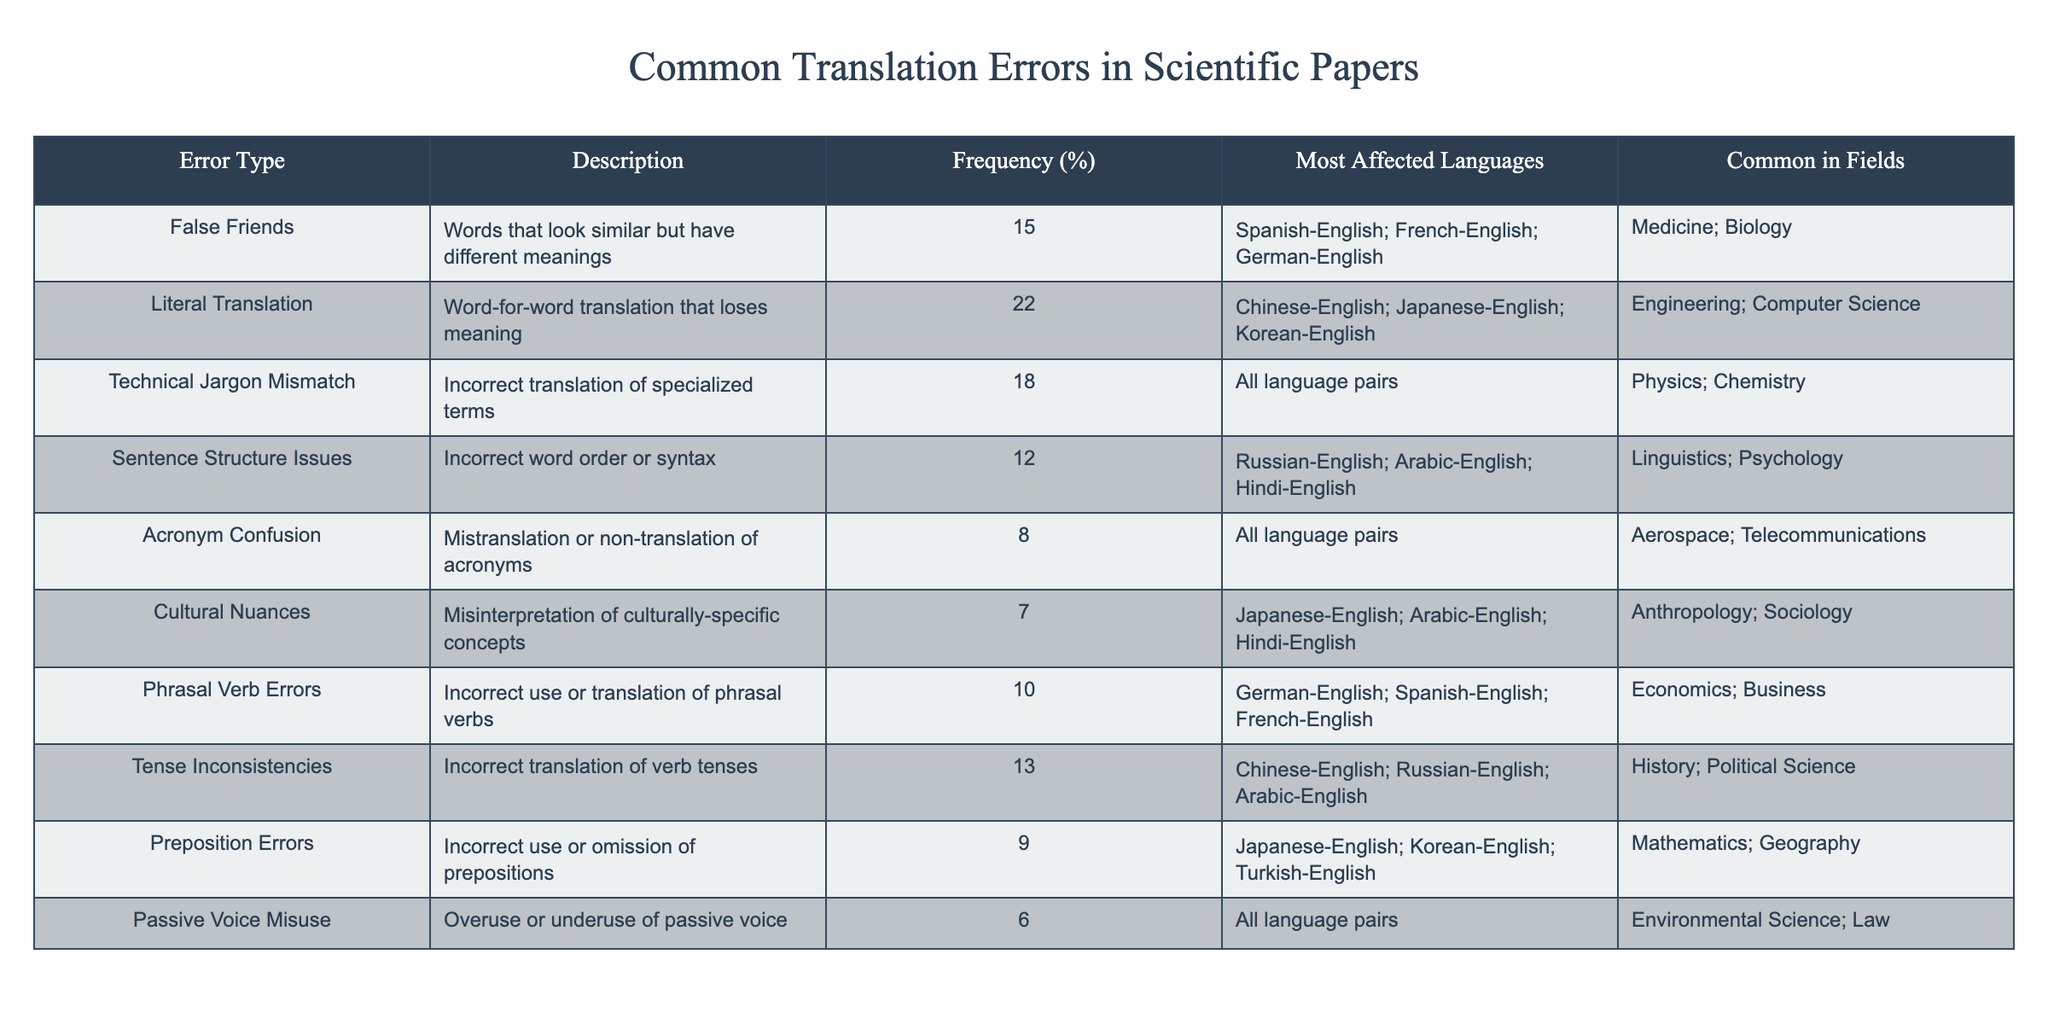What is the most common translation error by frequency? The highest frequency of a translation error is 22%, which corresponds to Literal Translation, as indicated in the Frequency column of the table.
Answer: Literal Translation Which language pairs are most affected by False Friends? The table lists Spanish-English, French-English, and German-English under the Most Affected Languages for the error type False Friends.
Answer: Spanish-English; French-English; German-English What percentage of errors is attributed to Acronym Confusion? The Frequency column shows that Acronym Confusion accounts for 8% of translation errors.
Answer: 8% What is the average frequency of all translation errors listed? To calculate the average, sum all frequencies (15 + 22 + 18 + 12 + 8 + 7 + 10 + 13 + 9 + 6 = 120) and divide by the number of error types (10), resulting in an average of 120 / 10 = 12.
Answer: 12% Is Cultural Nuances the least common error type? By checking the Frequency column, Cultural Nuances has a frequency of 7%, which is less than any other error type listed, confirming it as the least common.
Answer: Yes How many error types have a frequency greater than 10%? By reviewing the table, the error types with frequencies greater than 10% are Literal Translation (22%), Technical Jargon Mismatch (18%), False Friends (15%), Tense Inconsistencies (13%), and Sentence Structure Issues (12), totaling 5 error types.
Answer: 5 What types of errors are commonly found in the field of Engineering? The table indicates that Literal Translation and Technical Jargon Mismatch are the types of errors common in the field of Engineering.
Answer: Literal Translation; Technical Jargon Mismatch Which error type affects the field of Sociology? The table specifies that Cultural Nuances is the error type affecting the field of Sociology.
Answer: Cultural Nuances How many errors are common in all language pairs? A review of the table reveals that both Technical Jargon Mismatch and Acronym Confusion are common across all language pairs, resulting in a total of 2 error types.
Answer: 2 What is the difference in frequency between the most and least common translation errors? The most common error, Literal Translation, has a frequency of 22%, whereas the least common, Cultural Nuances, has a frequency of 7%. The difference is 22% - 7% = 15%.
Answer: 15% 